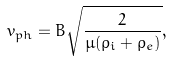<formula> <loc_0><loc_0><loc_500><loc_500>v _ { p h } = B \sqrt { \frac { 2 } { \mu ( \rho _ { i } + \rho _ { e } ) } } ,</formula> 